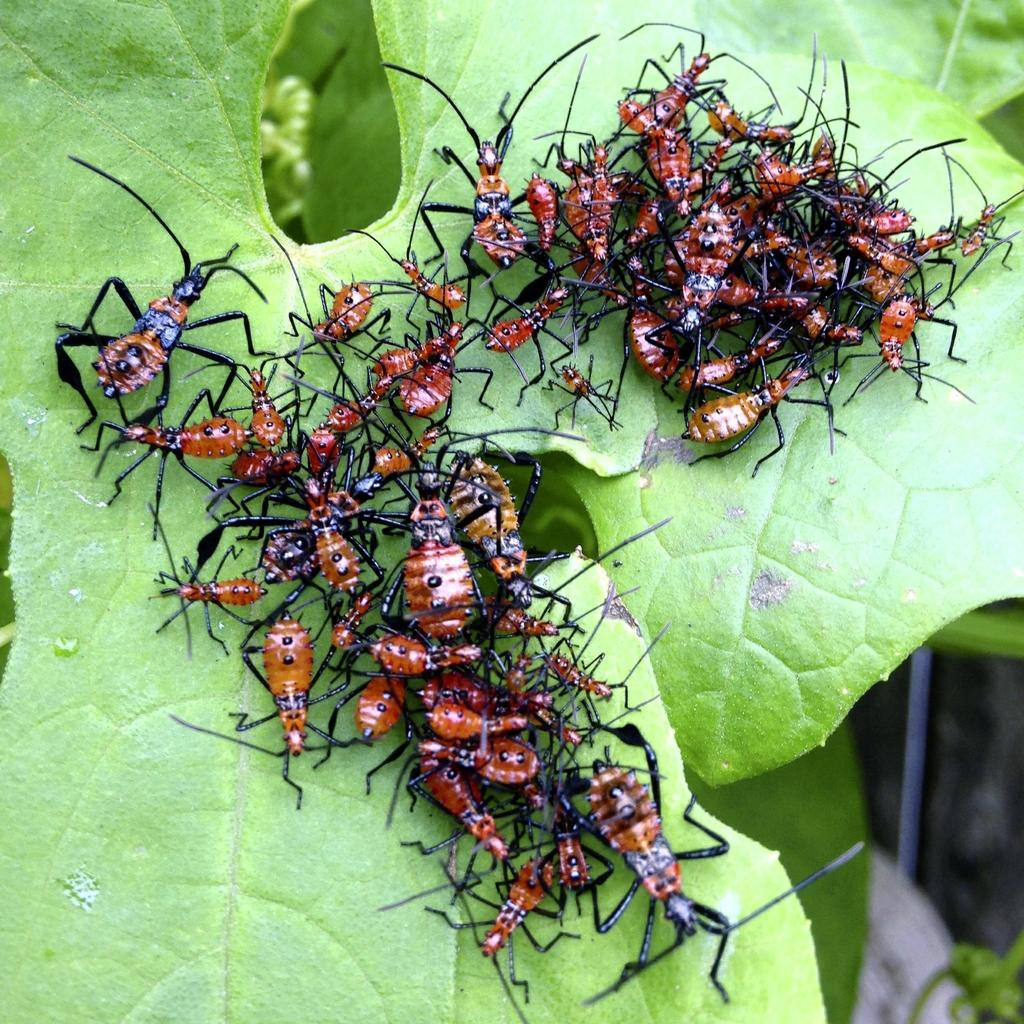What is the main subject of the image? The main subject of the image is a leaf with many insects on it. Can you describe the insects on the leaf? Unfortunately, the specific types of insects cannot be determined from the image. What is the setting of the image? The image appears to be set in a natural environment, likely outdoors. What type of peace symbol can be seen in the image? There is no peace symbol present in the image; it features a leaf with insects on it. What kind of steel structure is visible in the image? There is no steel structure visible in the image; it features a leaf with insects on it. 